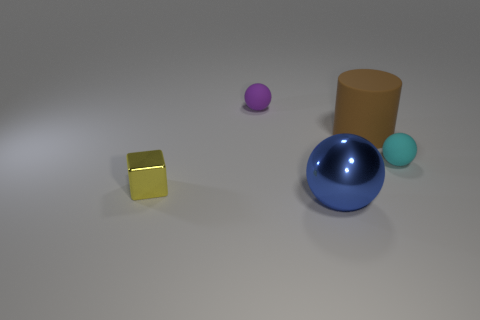Does the arrangement of the objects suggest any real-world application or scenario? Not specifically, the objects are placed randomly on a flat surface without any context that might suggest a real-world application. It appears to be more of an abstract composition or a render designed to showcase different colors and materials. 